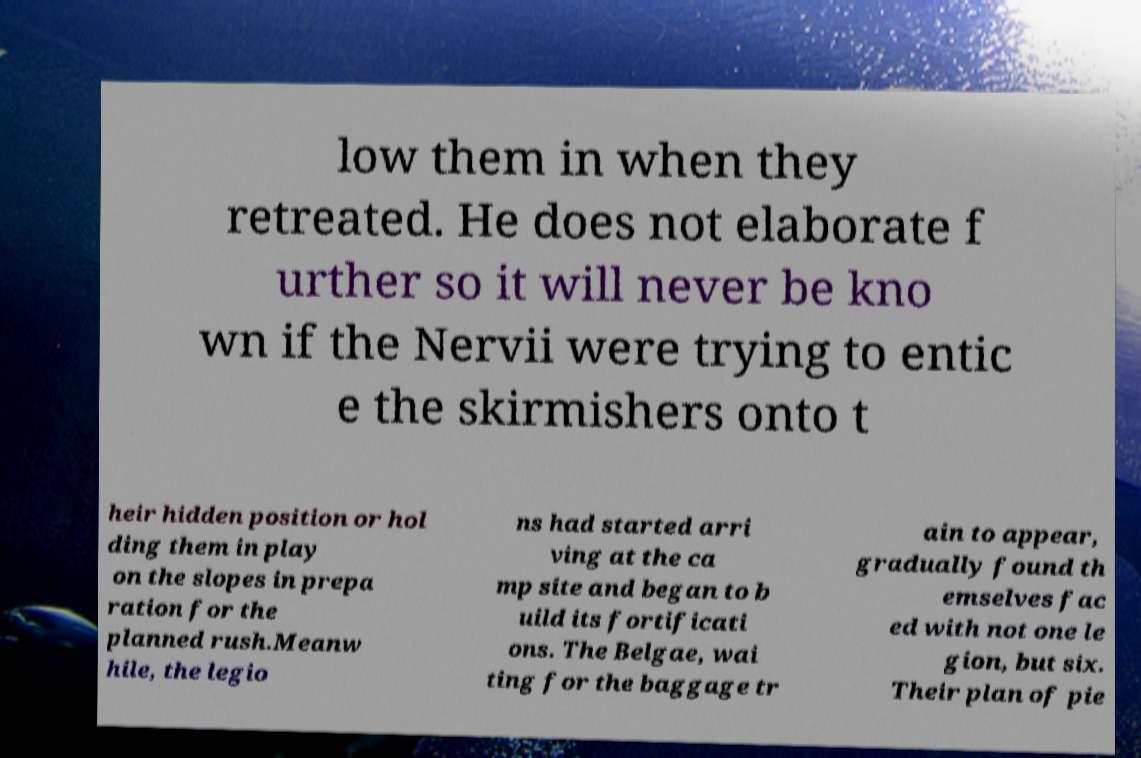What messages or text are displayed in this image? I need them in a readable, typed format. low them in when they retreated. He does not elaborate f urther so it will never be kno wn if the Nervii were trying to entic e the skirmishers onto t heir hidden position or hol ding them in play on the slopes in prepa ration for the planned rush.Meanw hile, the legio ns had started arri ving at the ca mp site and began to b uild its fortificati ons. The Belgae, wai ting for the baggage tr ain to appear, gradually found th emselves fac ed with not one le gion, but six. Their plan of pie 